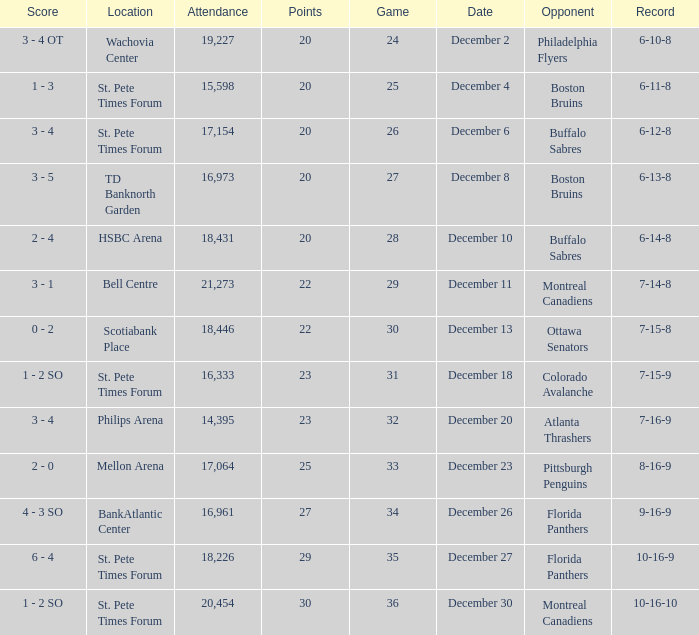What game has a 6-12-8 record? 26.0. 